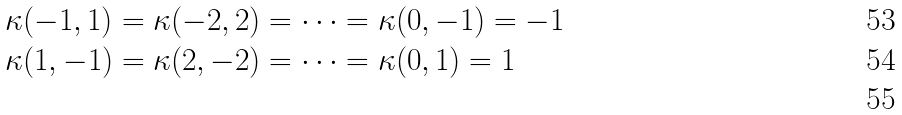Convert formula to latex. <formula><loc_0><loc_0><loc_500><loc_500>\kappa ( - 1 , 1 ) & = \kappa ( - 2 , 2 ) = \dots = \kappa ( 0 , - 1 ) = - 1 \\ \kappa ( 1 , - 1 ) & = \kappa ( 2 , - 2 ) = \dots = \kappa ( 0 , 1 ) = 1 \\</formula> 